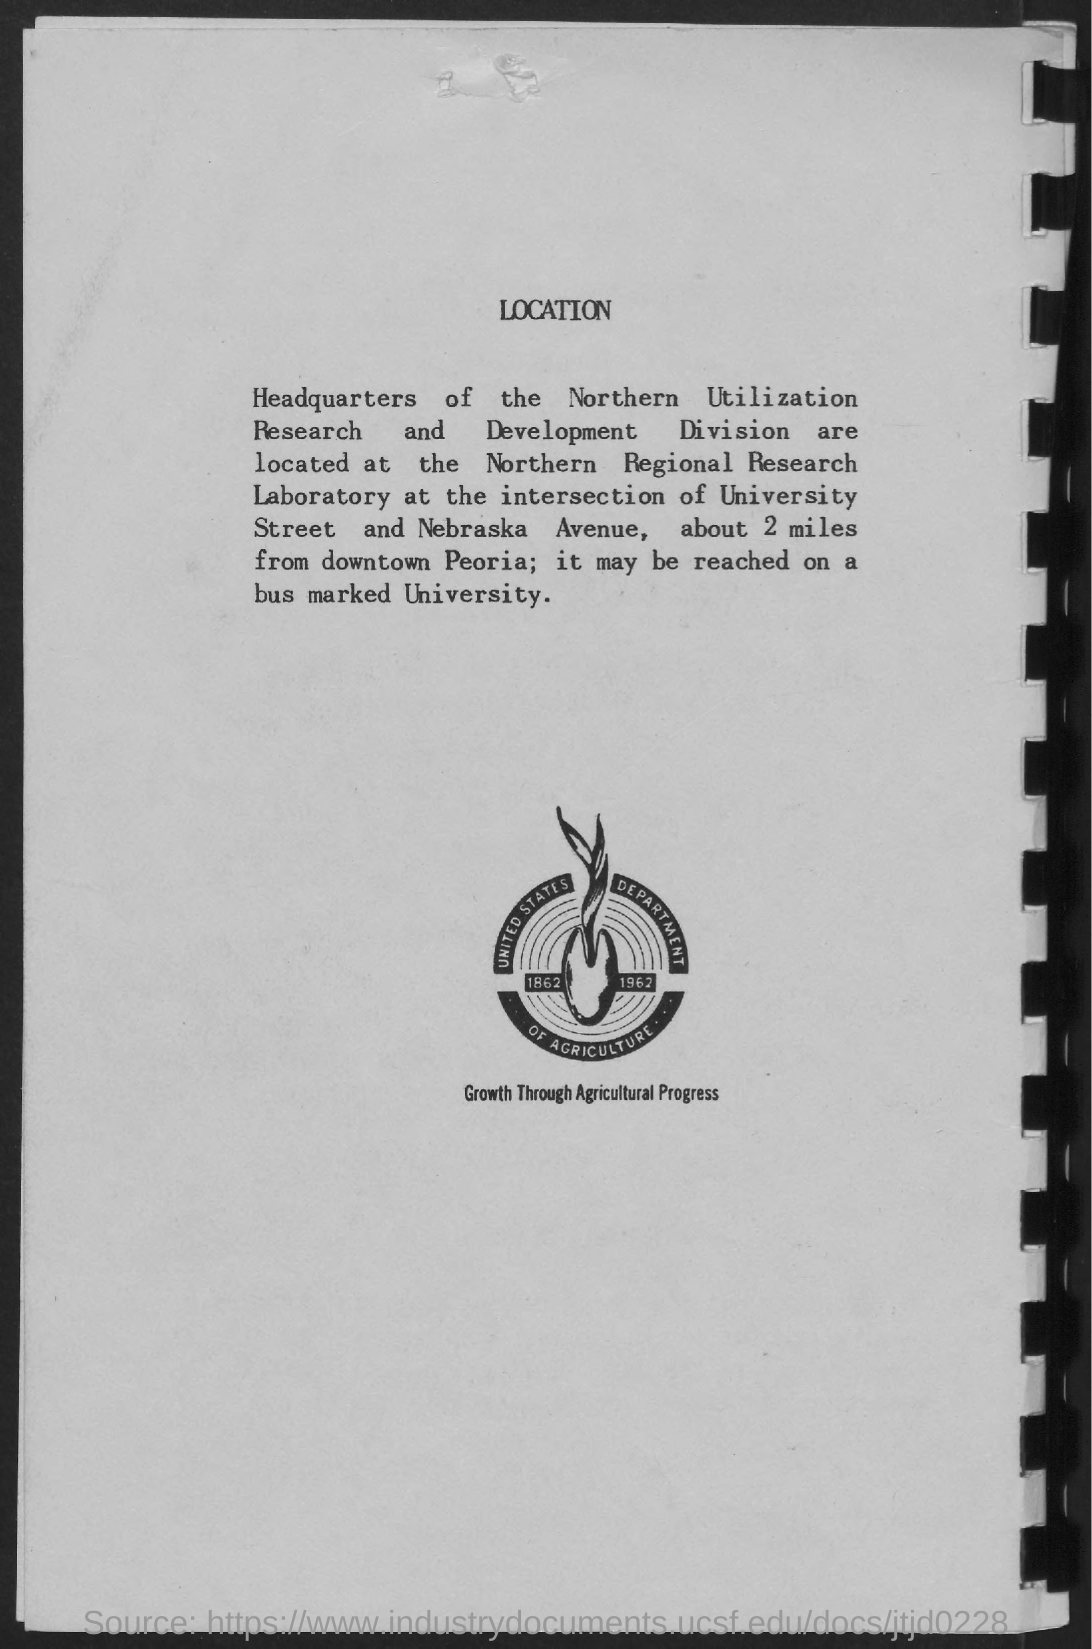What is the tagline of united states department of agriculture?
Ensure brevity in your answer.  Growth through Agricultural Progress. What is the heading of the page?
Your answer should be compact. Location. 